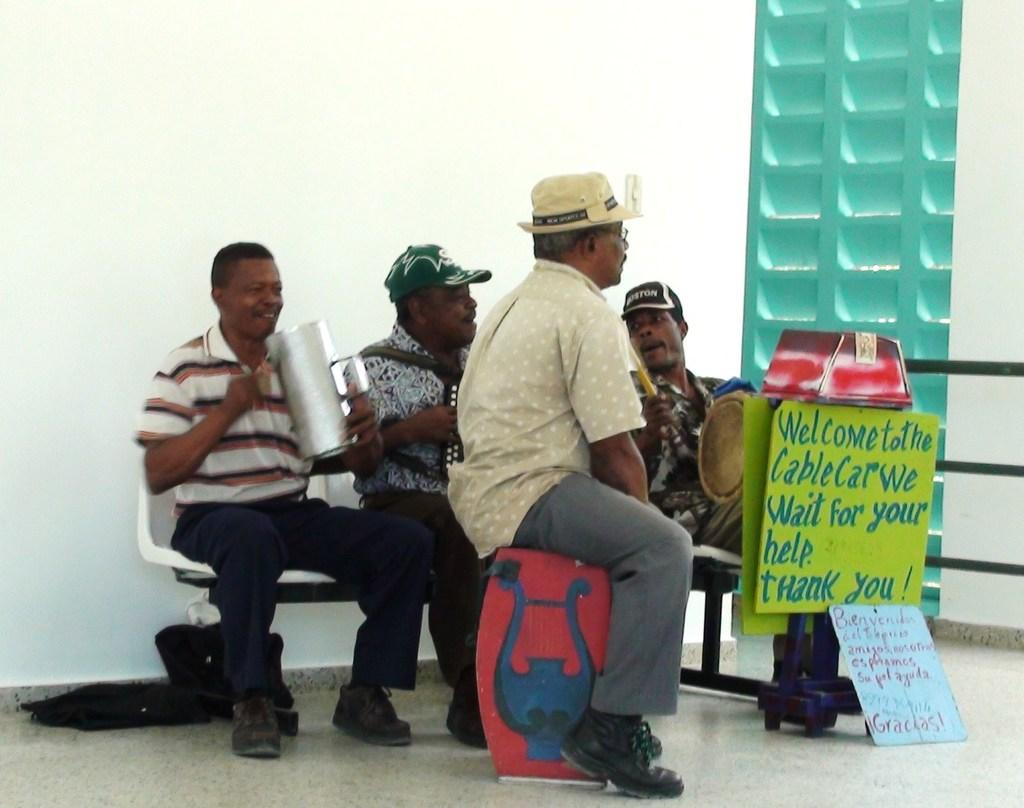How many people are in the image? There is a group of people in the image. Where are the people located in the image? The people are sitting in the center of the image. What can be seen on the right side of the image? There is a cable car poster on the right side of the image. What type of flowers are growing on the side of the cable car in the image? There are no flowers or cable cars present in the image; it only features a group of people sitting and a cable car poster on the right side. 